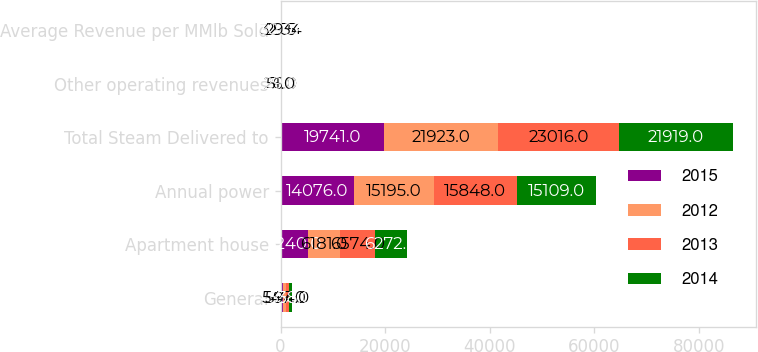<chart> <loc_0><loc_0><loc_500><loc_500><stacked_bar_chart><ecel><fcel>General<fcel>Apartment house<fcel>Annual power<fcel>Total Steam Delivered to<fcel>Other operating revenues<fcel>Average Revenue per MMlb Sold<nl><fcel>2015<fcel>425<fcel>5240<fcel>14076<fcel>19741<fcel>16<fcel>31<nl><fcel>2012<fcel>547<fcel>6181<fcel>15195<fcel>21923<fcel>26<fcel>32.34<nl><fcel>2013<fcel>594<fcel>6574<fcel>15848<fcel>23016<fcel>51<fcel>29.5<nl><fcel>2014<fcel>538<fcel>6272<fcel>15109<fcel>21919<fcel>29<fcel>30.02<nl></chart> 